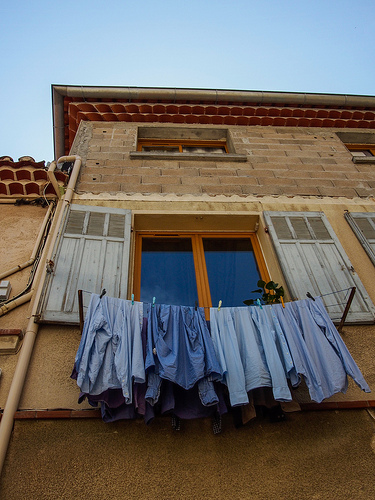<image>
Is there a rain gutter above the pole? Yes. The rain gutter is positioned above the pole in the vertical space, higher up in the scene. 